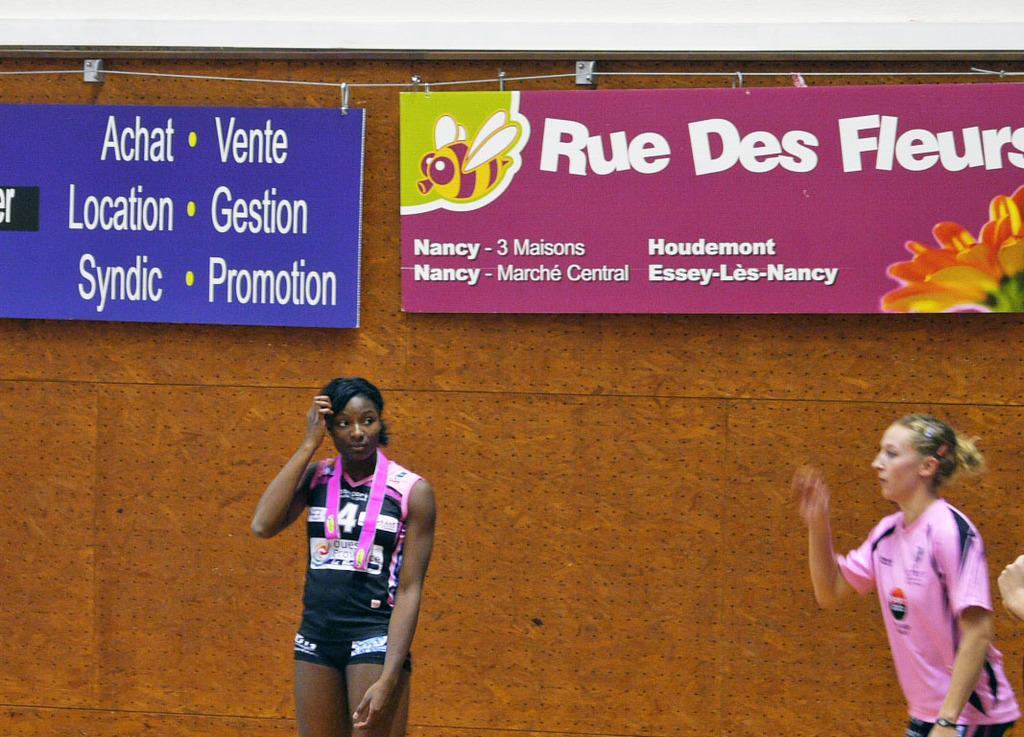Could you give a brief overview of what you see in this image? In this picture we can see two women and a woman standing and at the back of her we can see the wall, banners and some objects. 